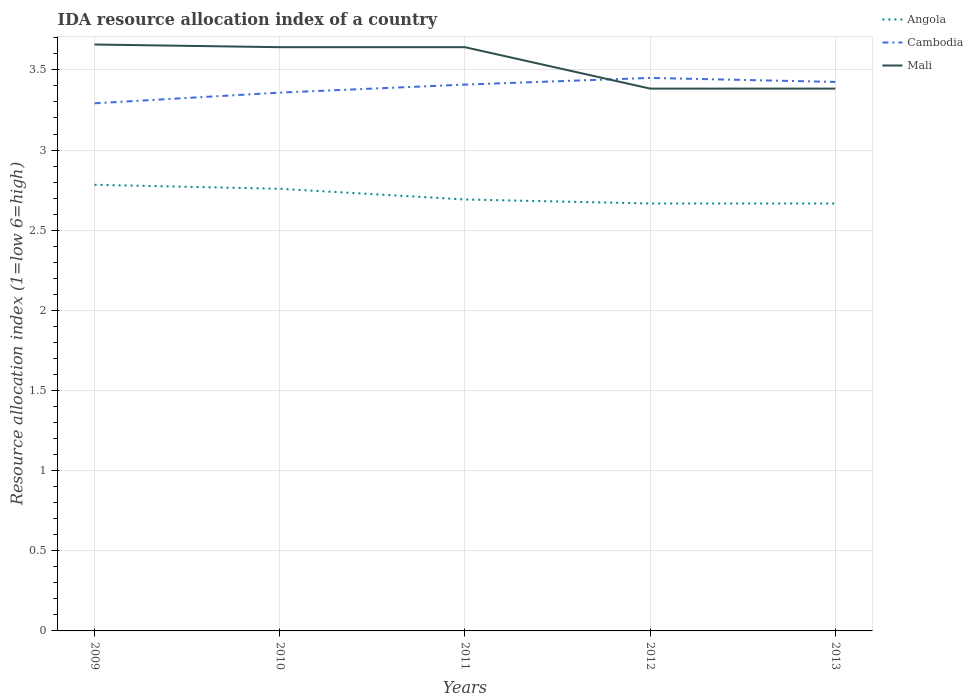How many different coloured lines are there?
Keep it short and to the point. 3. Is the number of lines equal to the number of legend labels?
Provide a short and direct response. Yes. Across all years, what is the maximum IDA resource allocation index in Cambodia?
Ensure brevity in your answer.  3.29. In which year was the IDA resource allocation index in Angola maximum?
Provide a short and direct response. 2012. What is the total IDA resource allocation index in Mali in the graph?
Ensure brevity in your answer.  0.27. What is the difference between the highest and the second highest IDA resource allocation index in Mali?
Your answer should be compact. 0.27. What is the difference between the highest and the lowest IDA resource allocation index in Mali?
Your answer should be compact. 3. Is the IDA resource allocation index in Angola strictly greater than the IDA resource allocation index in Cambodia over the years?
Make the answer very short. Yes. How many years are there in the graph?
Offer a terse response. 5. What is the difference between two consecutive major ticks on the Y-axis?
Your response must be concise. 0.5. Are the values on the major ticks of Y-axis written in scientific E-notation?
Your response must be concise. No. Does the graph contain any zero values?
Ensure brevity in your answer.  No. Where does the legend appear in the graph?
Your answer should be very brief. Top right. How many legend labels are there?
Provide a succinct answer. 3. What is the title of the graph?
Your answer should be compact. IDA resource allocation index of a country. Does "Costa Rica" appear as one of the legend labels in the graph?
Ensure brevity in your answer.  No. What is the label or title of the X-axis?
Offer a terse response. Years. What is the label or title of the Y-axis?
Keep it short and to the point. Resource allocation index (1=low 6=high). What is the Resource allocation index (1=low 6=high) in Angola in 2009?
Ensure brevity in your answer.  2.78. What is the Resource allocation index (1=low 6=high) of Cambodia in 2009?
Your answer should be compact. 3.29. What is the Resource allocation index (1=low 6=high) of Mali in 2009?
Make the answer very short. 3.66. What is the Resource allocation index (1=low 6=high) in Angola in 2010?
Ensure brevity in your answer.  2.76. What is the Resource allocation index (1=low 6=high) in Cambodia in 2010?
Offer a terse response. 3.36. What is the Resource allocation index (1=low 6=high) in Mali in 2010?
Offer a terse response. 3.64. What is the Resource allocation index (1=low 6=high) in Angola in 2011?
Keep it short and to the point. 2.69. What is the Resource allocation index (1=low 6=high) in Cambodia in 2011?
Ensure brevity in your answer.  3.41. What is the Resource allocation index (1=low 6=high) in Mali in 2011?
Offer a very short reply. 3.64. What is the Resource allocation index (1=low 6=high) of Angola in 2012?
Your answer should be very brief. 2.67. What is the Resource allocation index (1=low 6=high) in Cambodia in 2012?
Ensure brevity in your answer.  3.45. What is the Resource allocation index (1=low 6=high) in Mali in 2012?
Ensure brevity in your answer.  3.38. What is the Resource allocation index (1=low 6=high) in Angola in 2013?
Offer a very short reply. 2.67. What is the Resource allocation index (1=low 6=high) in Cambodia in 2013?
Your response must be concise. 3.42. What is the Resource allocation index (1=low 6=high) of Mali in 2013?
Give a very brief answer. 3.38. Across all years, what is the maximum Resource allocation index (1=low 6=high) of Angola?
Give a very brief answer. 2.78. Across all years, what is the maximum Resource allocation index (1=low 6=high) of Cambodia?
Offer a terse response. 3.45. Across all years, what is the maximum Resource allocation index (1=low 6=high) of Mali?
Keep it short and to the point. 3.66. Across all years, what is the minimum Resource allocation index (1=low 6=high) of Angola?
Your answer should be very brief. 2.67. Across all years, what is the minimum Resource allocation index (1=low 6=high) in Cambodia?
Keep it short and to the point. 3.29. Across all years, what is the minimum Resource allocation index (1=low 6=high) of Mali?
Ensure brevity in your answer.  3.38. What is the total Resource allocation index (1=low 6=high) of Angola in the graph?
Offer a very short reply. 13.57. What is the total Resource allocation index (1=low 6=high) in Cambodia in the graph?
Your answer should be very brief. 16.93. What is the total Resource allocation index (1=low 6=high) of Mali in the graph?
Ensure brevity in your answer.  17.71. What is the difference between the Resource allocation index (1=low 6=high) of Angola in 2009 and that in 2010?
Your response must be concise. 0.03. What is the difference between the Resource allocation index (1=low 6=high) of Cambodia in 2009 and that in 2010?
Make the answer very short. -0.07. What is the difference between the Resource allocation index (1=low 6=high) in Mali in 2009 and that in 2010?
Give a very brief answer. 0.02. What is the difference between the Resource allocation index (1=low 6=high) of Angola in 2009 and that in 2011?
Offer a terse response. 0.09. What is the difference between the Resource allocation index (1=low 6=high) of Cambodia in 2009 and that in 2011?
Your answer should be very brief. -0.12. What is the difference between the Resource allocation index (1=low 6=high) of Mali in 2009 and that in 2011?
Your response must be concise. 0.02. What is the difference between the Resource allocation index (1=low 6=high) of Angola in 2009 and that in 2012?
Provide a succinct answer. 0.12. What is the difference between the Resource allocation index (1=low 6=high) in Cambodia in 2009 and that in 2012?
Ensure brevity in your answer.  -0.16. What is the difference between the Resource allocation index (1=low 6=high) of Mali in 2009 and that in 2012?
Your answer should be compact. 0.28. What is the difference between the Resource allocation index (1=low 6=high) of Angola in 2009 and that in 2013?
Provide a succinct answer. 0.12. What is the difference between the Resource allocation index (1=low 6=high) of Cambodia in 2009 and that in 2013?
Provide a succinct answer. -0.13. What is the difference between the Resource allocation index (1=low 6=high) of Mali in 2009 and that in 2013?
Provide a short and direct response. 0.28. What is the difference between the Resource allocation index (1=low 6=high) in Angola in 2010 and that in 2011?
Your answer should be compact. 0.07. What is the difference between the Resource allocation index (1=low 6=high) of Cambodia in 2010 and that in 2011?
Provide a short and direct response. -0.05. What is the difference between the Resource allocation index (1=low 6=high) of Mali in 2010 and that in 2011?
Ensure brevity in your answer.  0. What is the difference between the Resource allocation index (1=low 6=high) of Angola in 2010 and that in 2012?
Give a very brief answer. 0.09. What is the difference between the Resource allocation index (1=low 6=high) in Cambodia in 2010 and that in 2012?
Ensure brevity in your answer.  -0.09. What is the difference between the Resource allocation index (1=low 6=high) of Mali in 2010 and that in 2012?
Make the answer very short. 0.26. What is the difference between the Resource allocation index (1=low 6=high) in Angola in 2010 and that in 2013?
Provide a short and direct response. 0.09. What is the difference between the Resource allocation index (1=low 6=high) of Cambodia in 2010 and that in 2013?
Give a very brief answer. -0.07. What is the difference between the Resource allocation index (1=low 6=high) in Mali in 2010 and that in 2013?
Your answer should be very brief. 0.26. What is the difference between the Resource allocation index (1=low 6=high) in Angola in 2011 and that in 2012?
Your answer should be compact. 0.03. What is the difference between the Resource allocation index (1=low 6=high) in Cambodia in 2011 and that in 2012?
Your answer should be compact. -0.04. What is the difference between the Resource allocation index (1=low 6=high) in Mali in 2011 and that in 2012?
Your answer should be very brief. 0.26. What is the difference between the Resource allocation index (1=low 6=high) of Angola in 2011 and that in 2013?
Keep it short and to the point. 0.03. What is the difference between the Resource allocation index (1=low 6=high) in Cambodia in 2011 and that in 2013?
Give a very brief answer. -0.02. What is the difference between the Resource allocation index (1=low 6=high) of Mali in 2011 and that in 2013?
Ensure brevity in your answer.  0.26. What is the difference between the Resource allocation index (1=low 6=high) in Angola in 2012 and that in 2013?
Provide a short and direct response. 0. What is the difference between the Resource allocation index (1=low 6=high) of Cambodia in 2012 and that in 2013?
Make the answer very short. 0.03. What is the difference between the Resource allocation index (1=low 6=high) of Angola in 2009 and the Resource allocation index (1=low 6=high) of Cambodia in 2010?
Your response must be concise. -0.57. What is the difference between the Resource allocation index (1=low 6=high) in Angola in 2009 and the Resource allocation index (1=low 6=high) in Mali in 2010?
Offer a very short reply. -0.86. What is the difference between the Resource allocation index (1=low 6=high) in Cambodia in 2009 and the Resource allocation index (1=low 6=high) in Mali in 2010?
Your response must be concise. -0.35. What is the difference between the Resource allocation index (1=low 6=high) of Angola in 2009 and the Resource allocation index (1=low 6=high) of Cambodia in 2011?
Make the answer very short. -0.62. What is the difference between the Resource allocation index (1=low 6=high) of Angola in 2009 and the Resource allocation index (1=low 6=high) of Mali in 2011?
Give a very brief answer. -0.86. What is the difference between the Resource allocation index (1=low 6=high) in Cambodia in 2009 and the Resource allocation index (1=low 6=high) in Mali in 2011?
Offer a terse response. -0.35. What is the difference between the Resource allocation index (1=low 6=high) in Angola in 2009 and the Resource allocation index (1=low 6=high) in Cambodia in 2012?
Provide a succinct answer. -0.67. What is the difference between the Resource allocation index (1=low 6=high) in Cambodia in 2009 and the Resource allocation index (1=low 6=high) in Mali in 2012?
Offer a very short reply. -0.09. What is the difference between the Resource allocation index (1=low 6=high) in Angola in 2009 and the Resource allocation index (1=low 6=high) in Cambodia in 2013?
Offer a very short reply. -0.64. What is the difference between the Resource allocation index (1=low 6=high) in Angola in 2009 and the Resource allocation index (1=low 6=high) in Mali in 2013?
Offer a very short reply. -0.6. What is the difference between the Resource allocation index (1=low 6=high) in Cambodia in 2009 and the Resource allocation index (1=low 6=high) in Mali in 2013?
Offer a very short reply. -0.09. What is the difference between the Resource allocation index (1=low 6=high) in Angola in 2010 and the Resource allocation index (1=low 6=high) in Cambodia in 2011?
Make the answer very short. -0.65. What is the difference between the Resource allocation index (1=low 6=high) in Angola in 2010 and the Resource allocation index (1=low 6=high) in Mali in 2011?
Give a very brief answer. -0.88. What is the difference between the Resource allocation index (1=low 6=high) of Cambodia in 2010 and the Resource allocation index (1=low 6=high) of Mali in 2011?
Give a very brief answer. -0.28. What is the difference between the Resource allocation index (1=low 6=high) of Angola in 2010 and the Resource allocation index (1=low 6=high) of Cambodia in 2012?
Your response must be concise. -0.69. What is the difference between the Resource allocation index (1=low 6=high) of Angola in 2010 and the Resource allocation index (1=low 6=high) of Mali in 2012?
Offer a terse response. -0.62. What is the difference between the Resource allocation index (1=low 6=high) of Cambodia in 2010 and the Resource allocation index (1=low 6=high) of Mali in 2012?
Give a very brief answer. -0.03. What is the difference between the Resource allocation index (1=low 6=high) in Angola in 2010 and the Resource allocation index (1=low 6=high) in Cambodia in 2013?
Keep it short and to the point. -0.67. What is the difference between the Resource allocation index (1=low 6=high) in Angola in 2010 and the Resource allocation index (1=low 6=high) in Mali in 2013?
Offer a very short reply. -0.62. What is the difference between the Resource allocation index (1=low 6=high) of Cambodia in 2010 and the Resource allocation index (1=low 6=high) of Mali in 2013?
Offer a very short reply. -0.03. What is the difference between the Resource allocation index (1=low 6=high) in Angola in 2011 and the Resource allocation index (1=low 6=high) in Cambodia in 2012?
Your response must be concise. -0.76. What is the difference between the Resource allocation index (1=low 6=high) in Angola in 2011 and the Resource allocation index (1=low 6=high) in Mali in 2012?
Your answer should be very brief. -0.69. What is the difference between the Resource allocation index (1=low 6=high) in Cambodia in 2011 and the Resource allocation index (1=low 6=high) in Mali in 2012?
Give a very brief answer. 0.03. What is the difference between the Resource allocation index (1=low 6=high) of Angola in 2011 and the Resource allocation index (1=low 6=high) of Cambodia in 2013?
Make the answer very short. -0.73. What is the difference between the Resource allocation index (1=low 6=high) of Angola in 2011 and the Resource allocation index (1=low 6=high) of Mali in 2013?
Your answer should be very brief. -0.69. What is the difference between the Resource allocation index (1=low 6=high) in Cambodia in 2011 and the Resource allocation index (1=low 6=high) in Mali in 2013?
Make the answer very short. 0.03. What is the difference between the Resource allocation index (1=low 6=high) in Angola in 2012 and the Resource allocation index (1=low 6=high) in Cambodia in 2013?
Keep it short and to the point. -0.76. What is the difference between the Resource allocation index (1=low 6=high) in Angola in 2012 and the Resource allocation index (1=low 6=high) in Mali in 2013?
Ensure brevity in your answer.  -0.72. What is the difference between the Resource allocation index (1=low 6=high) in Cambodia in 2012 and the Resource allocation index (1=low 6=high) in Mali in 2013?
Provide a succinct answer. 0.07. What is the average Resource allocation index (1=low 6=high) of Angola per year?
Make the answer very short. 2.71. What is the average Resource allocation index (1=low 6=high) of Cambodia per year?
Offer a very short reply. 3.39. What is the average Resource allocation index (1=low 6=high) in Mali per year?
Provide a succinct answer. 3.54. In the year 2009, what is the difference between the Resource allocation index (1=low 6=high) of Angola and Resource allocation index (1=low 6=high) of Cambodia?
Your answer should be compact. -0.51. In the year 2009, what is the difference between the Resource allocation index (1=low 6=high) in Angola and Resource allocation index (1=low 6=high) in Mali?
Your response must be concise. -0.88. In the year 2009, what is the difference between the Resource allocation index (1=low 6=high) in Cambodia and Resource allocation index (1=low 6=high) in Mali?
Your answer should be very brief. -0.37. In the year 2010, what is the difference between the Resource allocation index (1=low 6=high) in Angola and Resource allocation index (1=low 6=high) in Cambodia?
Your answer should be compact. -0.6. In the year 2010, what is the difference between the Resource allocation index (1=low 6=high) in Angola and Resource allocation index (1=low 6=high) in Mali?
Provide a succinct answer. -0.88. In the year 2010, what is the difference between the Resource allocation index (1=low 6=high) in Cambodia and Resource allocation index (1=low 6=high) in Mali?
Your answer should be very brief. -0.28. In the year 2011, what is the difference between the Resource allocation index (1=low 6=high) of Angola and Resource allocation index (1=low 6=high) of Cambodia?
Your response must be concise. -0.72. In the year 2011, what is the difference between the Resource allocation index (1=low 6=high) of Angola and Resource allocation index (1=low 6=high) of Mali?
Your answer should be compact. -0.95. In the year 2011, what is the difference between the Resource allocation index (1=low 6=high) of Cambodia and Resource allocation index (1=low 6=high) of Mali?
Keep it short and to the point. -0.23. In the year 2012, what is the difference between the Resource allocation index (1=low 6=high) of Angola and Resource allocation index (1=low 6=high) of Cambodia?
Your answer should be very brief. -0.78. In the year 2012, what is the difference between the Resource allocation index (1=low 6=high) of Angola and Resource allocation index (1=low 6=high) of Mali?
Your answer should be compact. -0.72. In the year 2012, what is the difference between the Resource allocation index (1=low 6=high) in Cambodia and Resource allocation index (1=low 6=high) in Mali?
Your answer should be compact. 0.07. In the year 2013, what is the difference between the Resource allocation index (1=low 6=high) in Angola and Resource allocation index (1=low 6=high) in Cambodia?
Keep it short and to the point. -0.76. In the year 2013, what is the difference between the Resource allocation index (1=low 6=high) in Angola and Resource allocation index (1=low 6=high) in Mali?
Offer a very short reply. -0.72. In the year 2013, what is the difference between the Resource allocation index (1=low 6=high) in Cambodia and Resource allocation index (1=low 6=high) in Mali?
Provide a succinct answer. 0.04. What is the ratio of the Resource allocation index (1=low 6=high) in Angola in 2009 to that in 2010?
Offer a terse response. 1.01. What is the ratio of the Resource allocation index (1=low 6=high) in Cambodia in 2009 to that in 2010?
Make the answer very short. 0.98. What is the ratio of the Resource allocation index (1=low 6=high) in Mali in 2009 to that in 2010?
Your response must be concise. 1. What is the ratio of the Resource allocation index (1=low 6=high) of Angola in 2009 to that in 2011?
Offer a terse response. 1.03. What is the ratio of the Resource allocation index (1=low 6=high) in Cambodia in 2009 to that in 2011?
Ensure brevity in your answer.  0.97. What is the ratio of the Resource allocation index (1=low 6=high) in Angola in 2009 to that in 2012?
Provide a short and direct response. 1.04. What is the ratio of the Resource allocation index (1=low 6=high) of Cambodia in 2009 to that in 2012?
Give a very brief answer. 0.95. What is the ratio of the Resource allocation index (1=low 6=high) of Mali in 2009 to that in 2012?
Make the answer very short. 1.08. What is the ratio of the Resource allocation index (1=low 6=high) in Angola in 2009 to that in 2013?
Give a very brief answer. 1.04. What is the ratio of the Resource allocation index (1=low 6=high) of Cambodia in 2009 to that in 2013?
Your answer should be very brief. 0.96. What is the ratio of the Resource allocation index (1=low 6=high) in Mali in 2009 to that in 2013?
Ensure brevity in your answer.  1.08. What is the ratio of the Resource allocation index (1=low 6=high) of Angola in 2010 to that in 2011?
Keep it short and to the point. 1.02. What is the ratio of the Resource allocation index (1=low 6=high) of Mali in 2010 to that in 2011?
Your answer should be very brief. 1. What is the ratio of the Resource allocation index (1=low 6=high) of Angola in 2010 to that in 2012?
Make the answer very short. 1.03. What is the ratio of the Resource allocation index (1=low 6=high) in Cambodia in 2010 to that in 2012?
Provide a succinct answer. 0.97. What is the ratio of the Resource allocation index (1=low 6=high) of Mali in 2010 to that in 2012?
Keep it short and to the point. 1.08. What is the ratio of the Resource allocation index (1=low 6=high) of Angola in 2010 to that in 2013?
Give a very brief answer. 1.03. What is the ratio of the Resource allocation index (1=low 6=high) of Cambodia in 2010 to that in 2013?
Make the answer very short. 0.98. What is the ratio of the Resource allocation index (1=low 6=high) of Mali in 2010 to that in 2013?
Make the answer very short. 1.08. What is the ratio of the Resource allocation index (1=low 6=high) of Angola in 2011 to that in 2012?
Offer a terse response. 1.01. What is the ratio of the Resource allocation index (1=low 6=high) in Cambodia in 2011 to that in 2012?
Provide a short and direct response. 0.99. What is the ratio of the Resource allocation index (1=low 6=high) in Mali in 2011 to that in 2012?
Provide a succinct answer. 1.08. What is the ratio of the Resource allocation index (1=low 6=high) in Angola in 2011 to that in 2013?
Your response must be concise. 1.01. What is the ratio of the Resource allocation index (1=low 6=high) of Mali in 2011 to that in 2013?
Your answer should be compact. 1.08. What is the ratio of the Resource allocation index (1=low 6=high) of Angola in 2012 to that in 2013?
Your response must be concise. 1. What is the ratio of the Resource allocation index (1=low 6=high) of Cambodia in 2012 to that in 2013?
Make the answer very short. 1.01. What is the ratio of the Resource allocation index (1=low 6=high) of Mali in 2012 to that in 2013?
Provide a short and direct response. 1. What is the difference between the highest and the second highest Resource allocation index (1=low 6=high) in Angola?
Your answer should be compact. 0.03. What is the difference between the highest and the second highest Resource allocation index (1=low 6=high) of Cambodia?
Offer a terse response. 0.03. What is the difference between the highest and the second highest Resource allocation index (1=low 6=high) in Mali?
Your answer should be very brief. 0.02. What is the difference between the highest and the lowest Resource allocation index (1=low 6=high) in Angola?
Ensure brevity in your answer.  0.12. What is the difference between the highest and the lowest Resource allocation index (1=low 6=high) in Cambodia?
Offer a very short reply. 0.16. What is the difference between the highest and the lowest Resource allocation index (1=low 6=high) in Mali?
Your response must be concise. 0.28. 